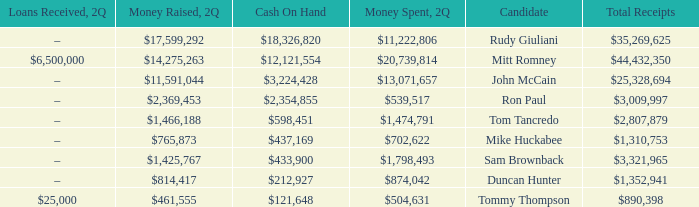I'm looking to parse the entire table for insights. Could you assist me with that? {'header': ['Loans Received, 2Q', 'Money Raised, 2Q', 'Cash On Hand', 'Money Spent, 2Q', 'Candidate', 'Total Receipts'], 'rows': [['–', '$17,599,292', '$18,326,820', '$11,222,806', 'Rudy Giuliani', '$35,269,625'], ['$6,500,000', '$14,275,263', '$12,121,554', '$20,739,814', 'Mitt Romney', '$44,432,350'], ['–', '$11,591,044', '$3,224,428', '$13,071,657', 'John McCain', '$25,328,694'], ['–', '$2,369,453', '$2,354,855', '$539,517', 'Ron Paul', '$3,009,997'], ['–', '$1,466,188', '$598,451', '$1,474,791', 'Tom Tancredo', '$2,807,879'], ['–', '$765,873', '$437,169', '$702,622', 'Mike Huckabee', '$1,310,753'], ['–', '$1,425,767', '$433,900', '$1,798,493', 'Sam Brownback', '$3,321,965'], ['–', '$814,417', '$212,927', '$874,042', 'Duncan Hunter', '$1,352,941'], ['$25,000', '$461,555', '$121,648', '$504,631', 'Tommy Thompson', '$890,398']]} Name the money raised when 2Q has money spent and 2Q is $874,042 $814,417. 